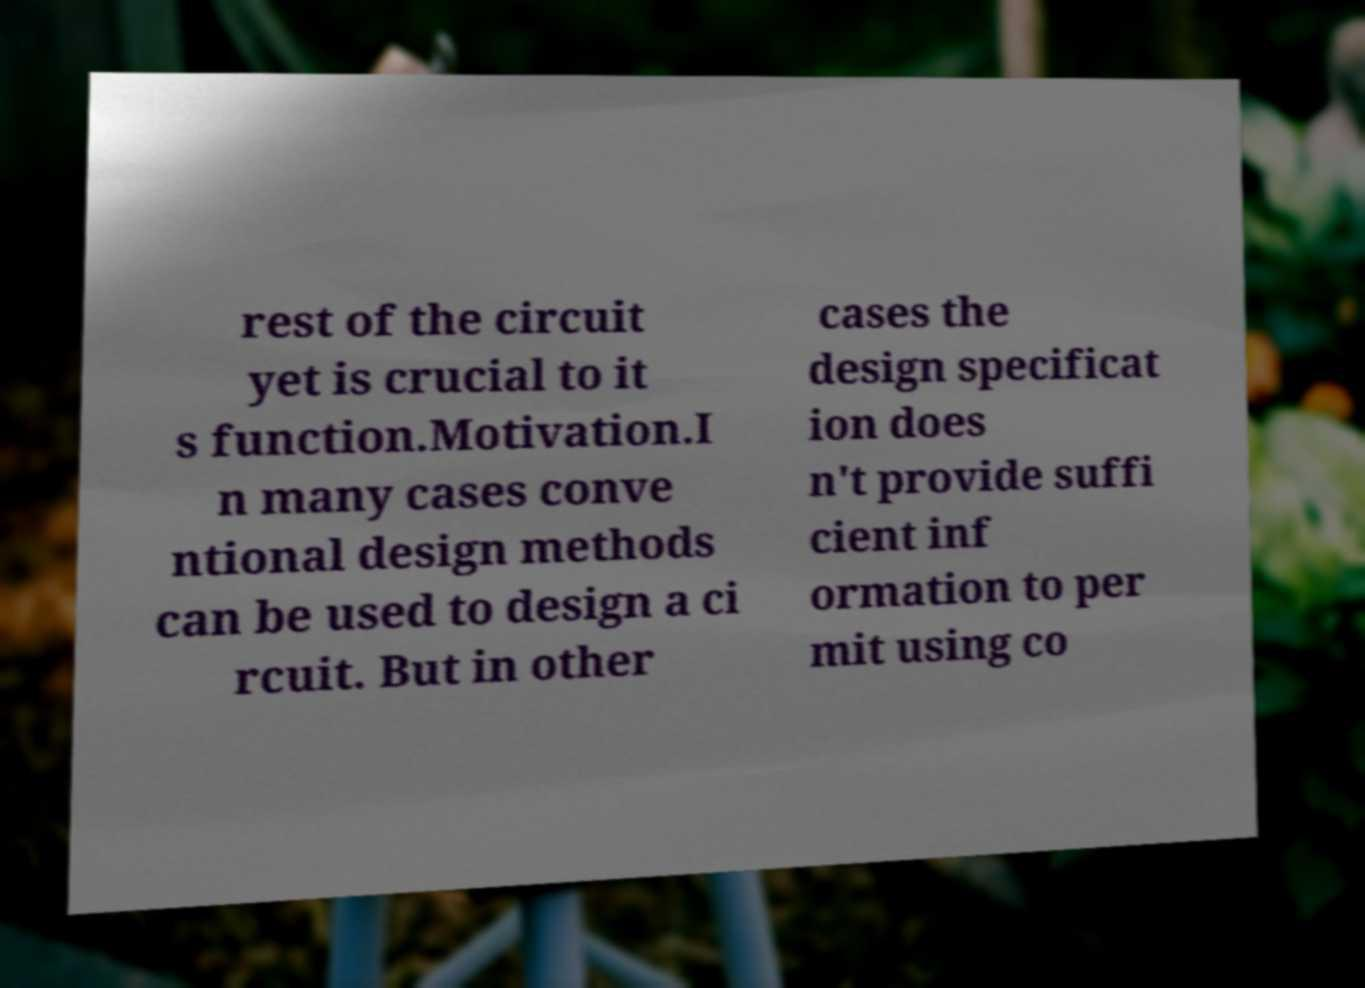Please read and relay the text visible in this image. What does it say? rest of the circuit yet is crucial to it s function.Motivation.I n many cases conve ntional design methods can be used to design a ci rcuit. But in other cases the design specificat ion does n't provide suffi cient inf ormation to per mit using co 